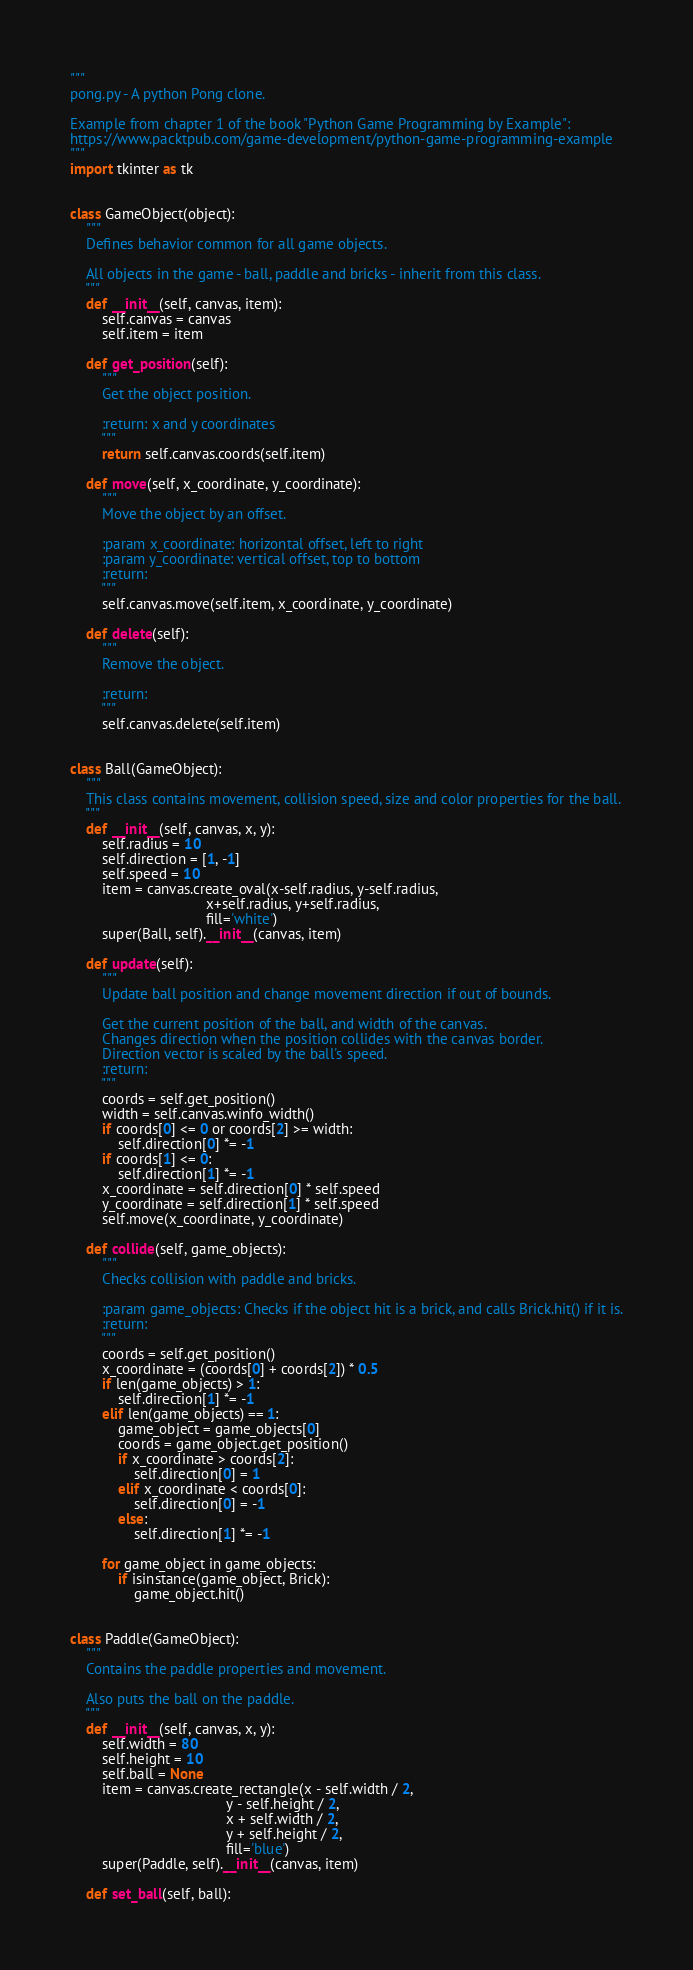<code> <loc_0><loc_0><loc_500><loc_500><_Python_>"""
pong.py - A python Pong clone.

Example from chapter 1 of the book "Python Game Programming by Example":
https://www.packtpub.com/game-development/python-game-programming-example
"""
import tkinter as tk


class GameObject(object):
    """
    Defines behavior common for all game objects.

    All objects in the game - ball, paddle and bricks - inherit from this class.
    """
    def __init__(self, canvas, item):
        self.canvas = canvas
        self.item = item

    def get_position(self):
        """
        Get the object position.

        :return: x and y coordinates
        """
        return self.canvas.coords(self.item)

    def move(self, x_coordinate, y_coordinate):
        """
        Move the object by an offset.

        :param x_coordinate: horizontal offset, left to right
        :param y_coordinate: vertical offset, top to bottom
        :return:
        """
        self.canvas.move(self.item, x_coordinate, y_coordinate)

    def delete(self):
        """
        Remove the object.

        :return:
        """
        self.canvas.delete(self.item)


class Ball(GameObject):
    """
    This class contains movement, collision speed, size and color properties for the ball.
    """
    def __init__(self, canvas, x, y):
        self.radius = 10
        self.direction = [1, -1]
        self.speed = 10
        item = canvas.create_oval(x-self.radius, y-self.radius,
                                  x+self.radius, y+self.radius,
                                  fill='white')
        super(Ball, self).__init__(canvas, item)

    def update(self):
        """
        Update ball position and change movement direction if out of bounds.

        Get the current position of the ball, and width of the canvas.
        Changes direction when the position collides with the canvas border.
        Direction vector is scaled by the ball's speed.
        :return:
        """
        coords = self.get_position()
        width = self.canvas.winfo_width()
        if coords[0] <= 0 or coords[2] >= width:
            self.direction[0] *= -1
        if coords[1] <= 0:
            self.direction[1] *= -1
        x_coordinate = self.direction[0] * self.speed
        y_coordinate = self.direction[1] * self.speed
        self.move(x_coordinate, y_coordinate)

    def collide(self, game_objects):
        """
        Checks collision with paddle and bricks.

        :param game_objects: Checks if the object hit is a brick, and calls Brick.hit() if it is.
        :return:
        """
        coords = self.get_position()
        x_coordinate = (coords[0] + coords[2]) * 0.5
        if len(game_objects) > 1:
            self.direction[1] *= -1
        elif len(game_objects) == 1:
            game_object = game_objects[0]
            coords = game_object.get_position()
            if x_coordinate > coords[2]:
                self.direction[0] = 1
            elif x_coordinate < coords[0]:
                self.direction[0] = -1
            else:
                self.direction[1] *= -1

        for game_object in game_objects:
            if isinstance(game_object, Brick):
                game_object.hit()


class Paddle(GameObject):
    """
    Contains the paddle properties and movement.

    Also puts the ball on the paddle.
    """
    def __init__(self, canvas, x, y):
        self.width = 80
        self.height = 10
        self.ball = None
        item = canvas.create_rectangle(x - self.width / 2,
                                       y - self.height / 2,
                                       x + self.width / 2,
                                       y + self.height / 2,
                                       fill='blue')
        super(Paddle, self).__init__(canvas, item)

    def set_ball(self, ball):</code> 